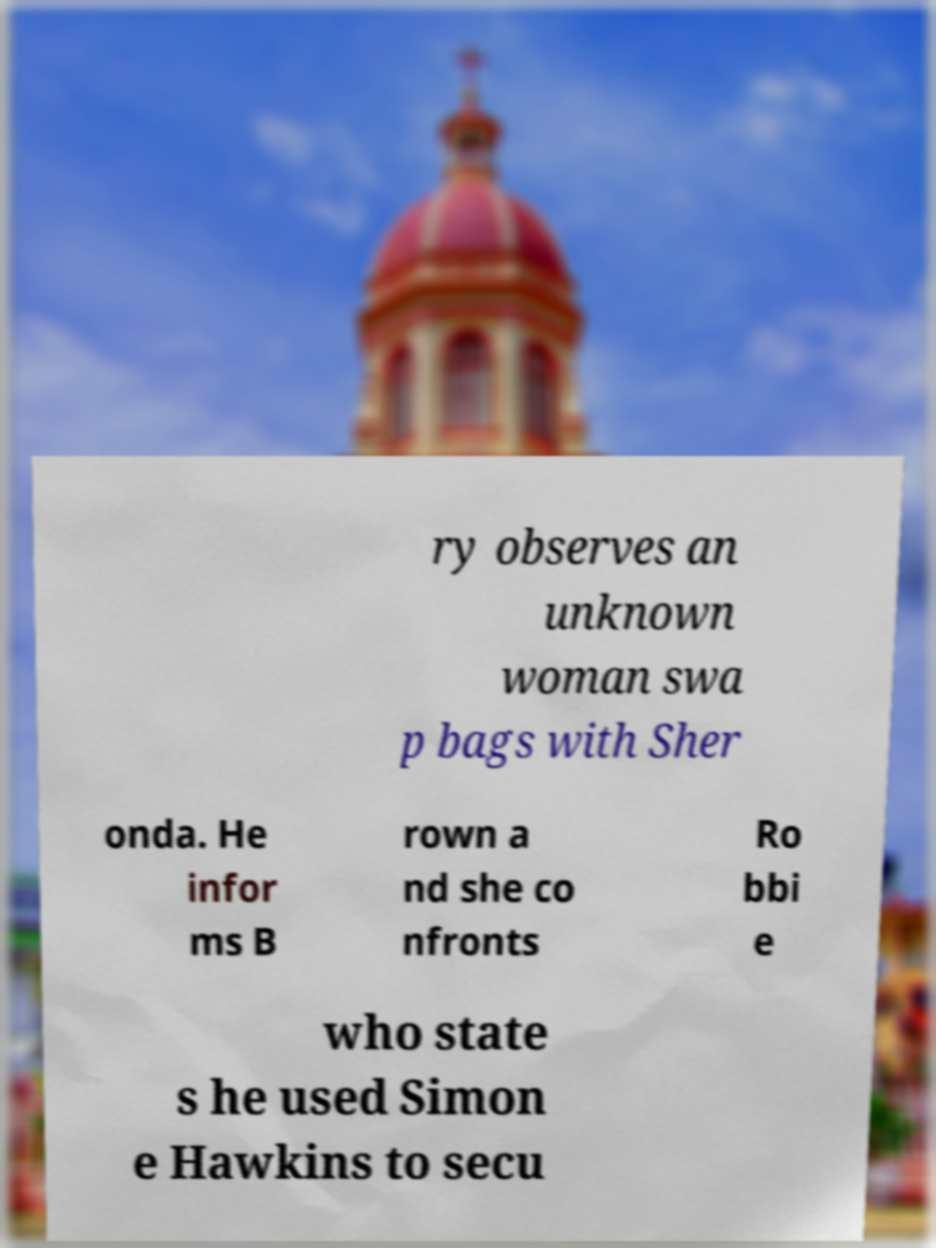Can you accurately transcribe the text from the provided image for me? ry observes an unknown woman swa p bags with Sher onda. He infor ms B rown a nd she co nfronts Ro bbi e who state s he used Simon e Hawkins to secu 